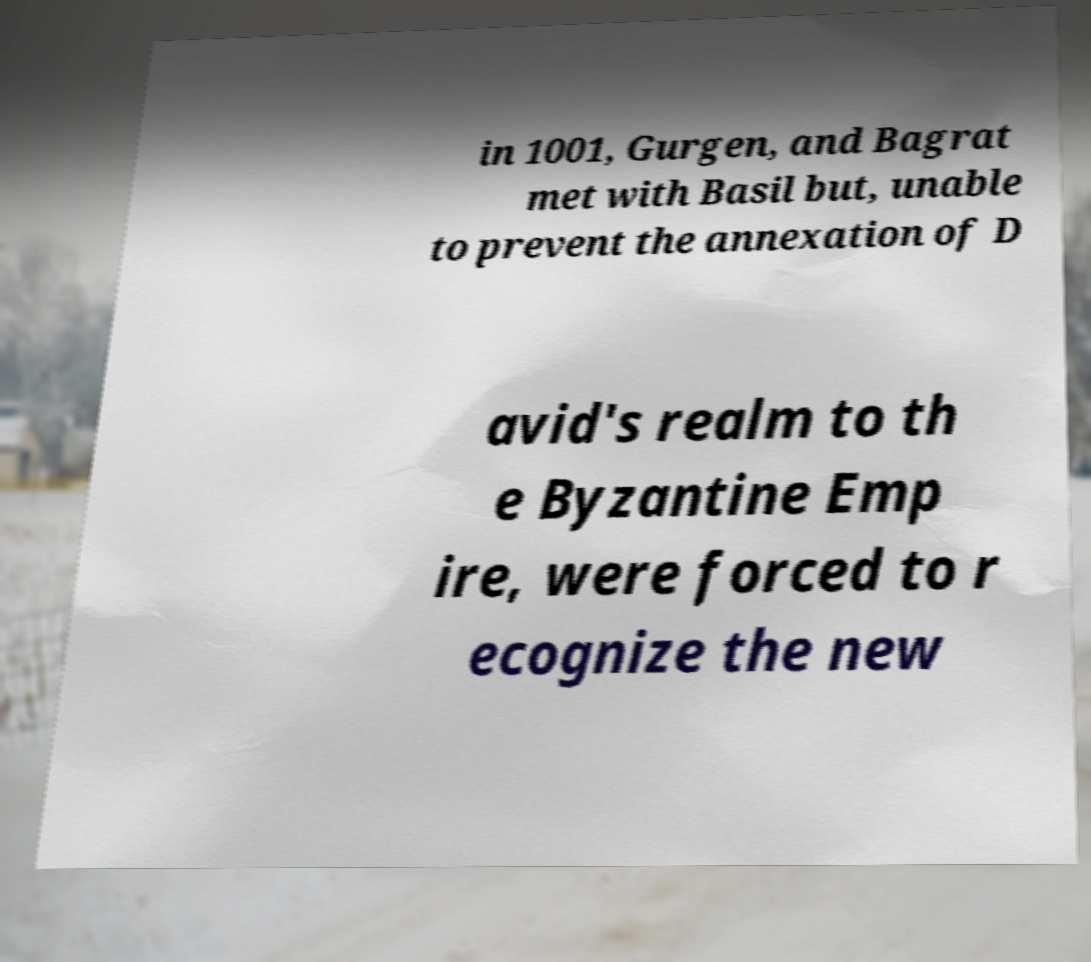Can you read and provide the text displayed in the image?This photo seems to have some interesting text. Can you extract and type it out for me? in 1001, Gurgen, and Bagrat met with Basil but, unable to prevent the annexation of D avid's realm to th e Byzantine Emp ire, were forced to r ecognize the new 